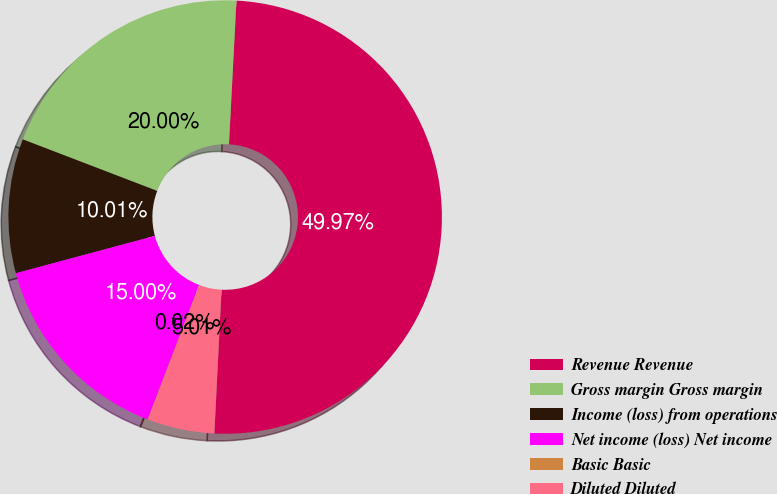Convert chart to OTSL. <chart><loc_0><loc_0><loc_500><loc_500><pie_chart><fcel>Revenue Revenue<fcel>Gross margin Gross margin<fcel>Income (loss) from operations<fcel>Net income (loss) Net income<fcel>Basic Basic<fcel>Diluted Diluted<nl><fcel>49.97%<fcel>20.0%<fcel>10.01%<fcel>15.0%<fcel>0.02%<fcel>5.01%<nl></chart> 